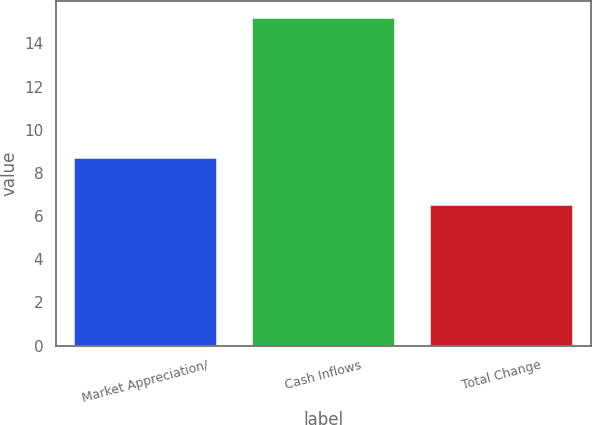Convert chart. <chart><loc_0><loc_0><loc_500><loc_500><bar_chart><fcel>Market Appreciation/<fcel>Cash Inflows<fcel>Total Change<nl><fcel>8.7<fcel>15.2<fcel>6.5<nl></chart> 